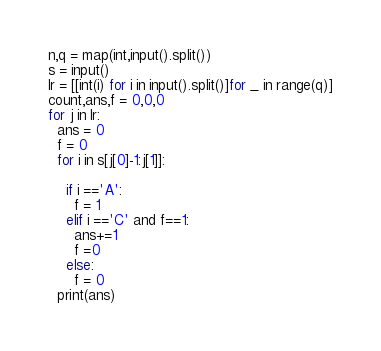Convert code to text. <code><loc_0><loc_0><loc_500><loc_500><_Python_>n,q = map(int,input().split())
s = input()
lr = [[int(i) for i in input().split()]for _ in range(q)]
count,ans,f = 0,0,0
for j in lr:
  ans = 0
  f = 0
  for i in s[j[0]-1:j[1]]:
    
    if i =='A':
      f = 1
    elif i =='C' and f==1:
      ans+=1
      f =0
    else:
      f = 0
  print(ans)
</code> 